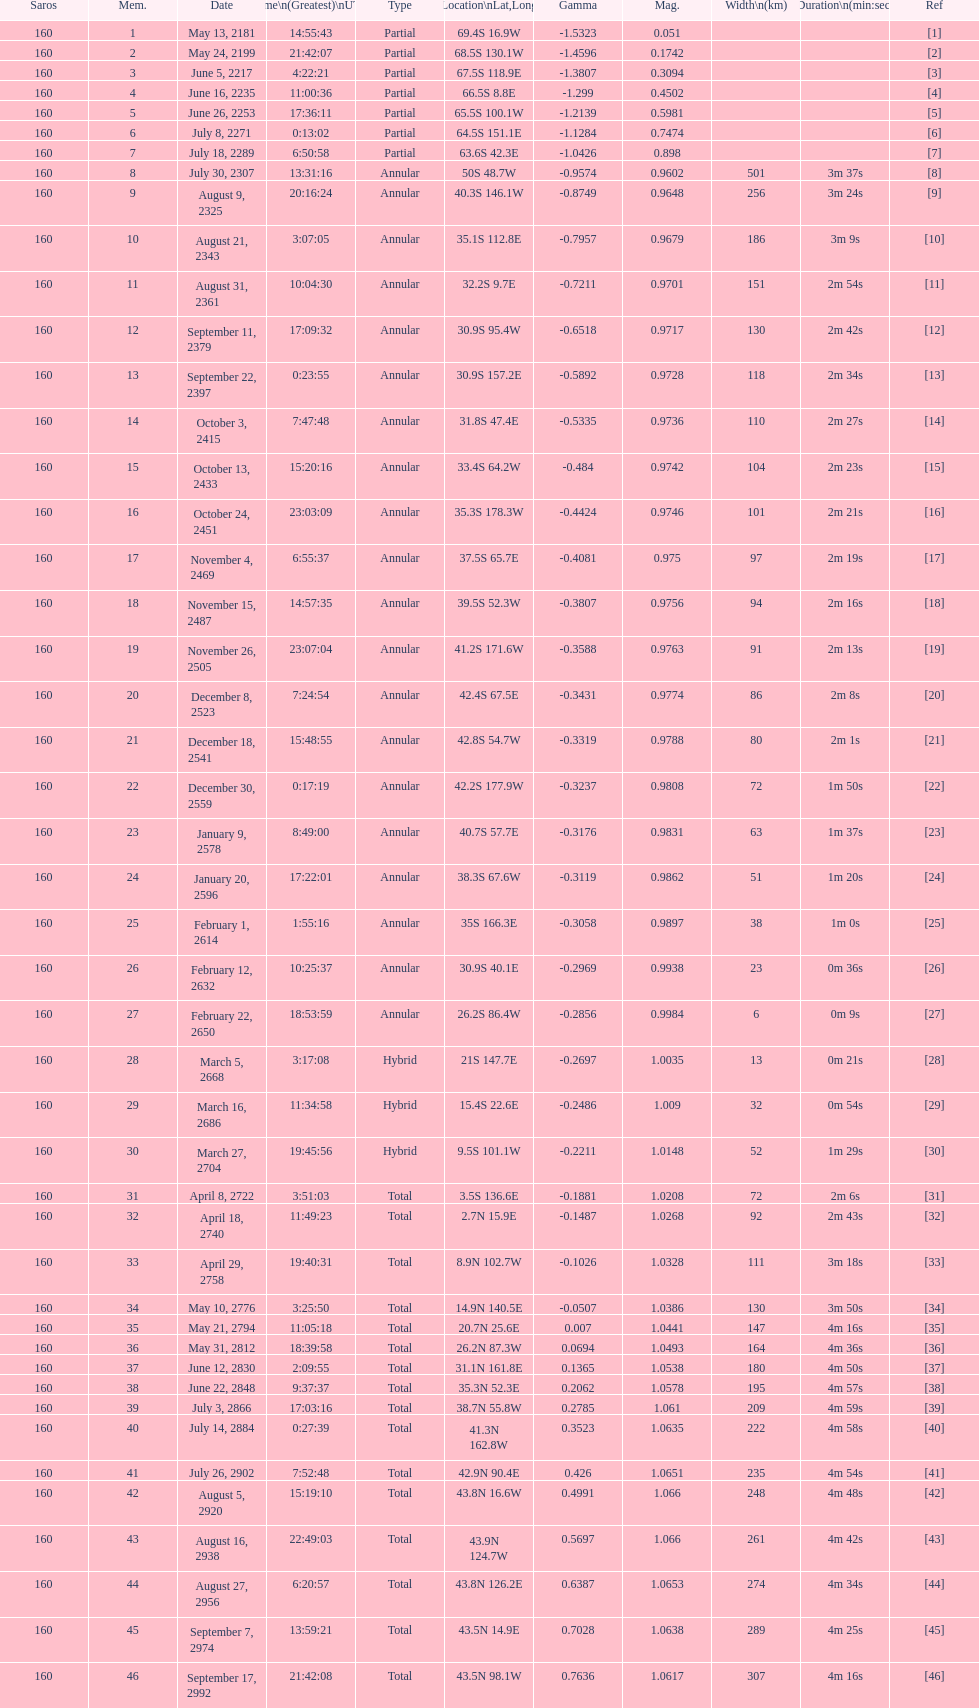Name one that has the same latitude as member number 12. 13. 